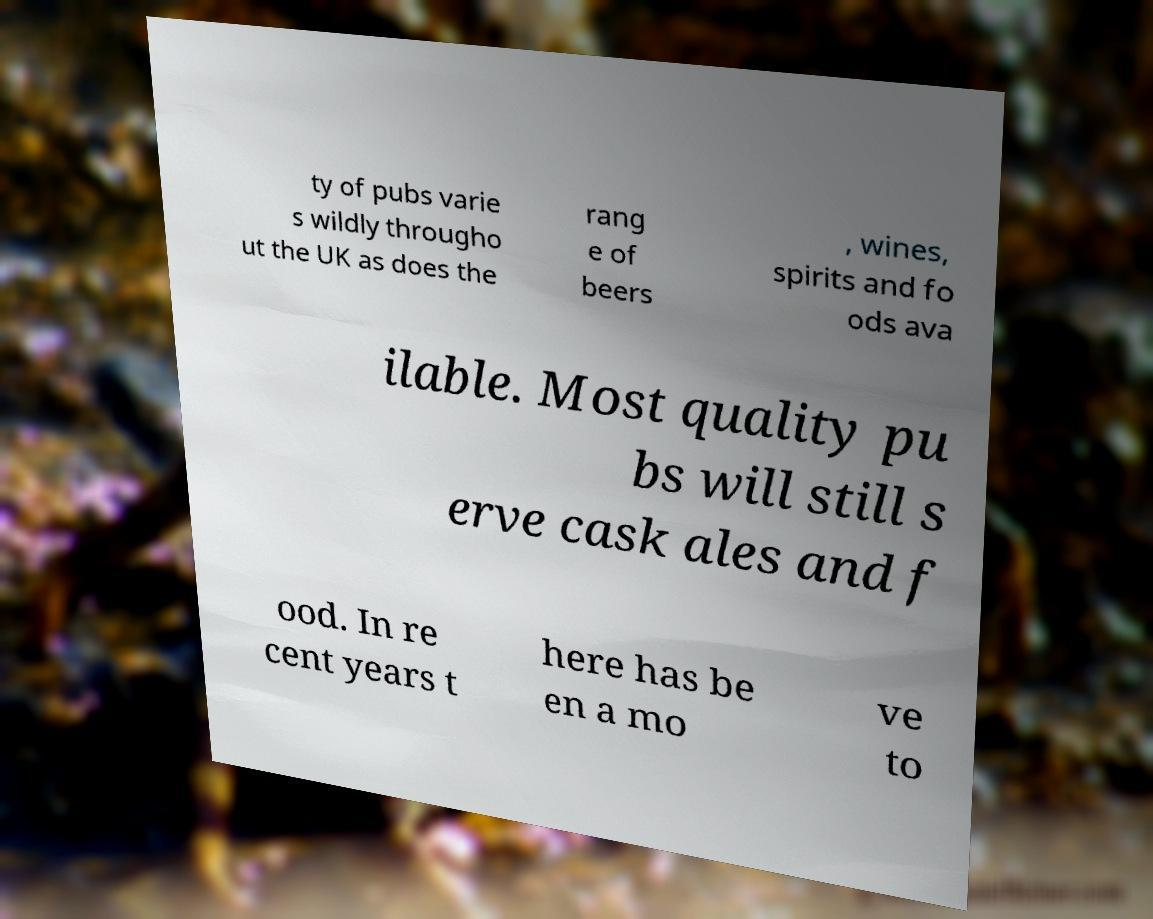Can you read and provide the text displayed in the image?This photo seems to have some interesting text. Can you extract and type it out for me? ty of pubs varie s wildly througho ut the UK as does the rang e of beers , wines, spirits and fo ods ava ilable. Most quality pu bs will still s erve cask ales and f ood. In re cent years t here has be en a mo ve to 